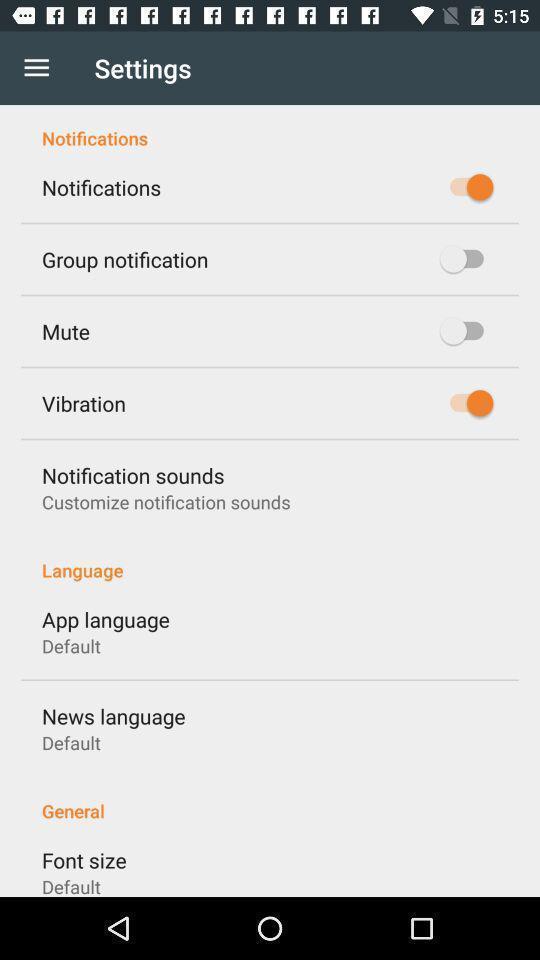What is the overall content of this screenshot? Settings page. 